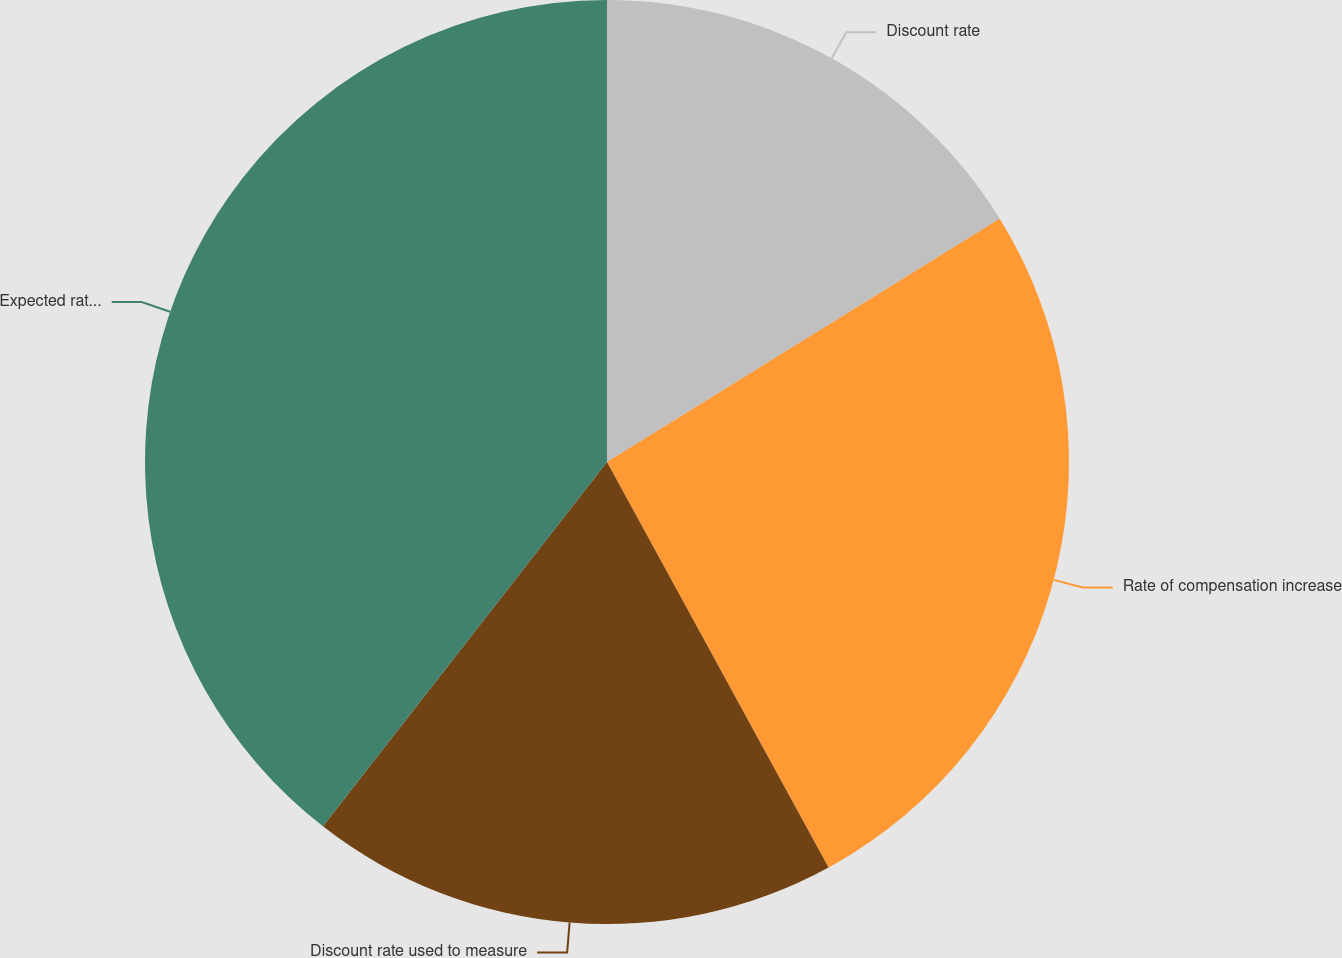<chart> <loc_0><loc_0><loc_500><loc_500><pie_chart><fcel>Discount rate<fcel>Rate of compensation increase<fcel>Discount rate used to measure<fcel>Expected rate of return on<nl><fcel>16.17%<fcel>25.87%<fcel>18.5%<fcel>39.46%<nl></chart> 